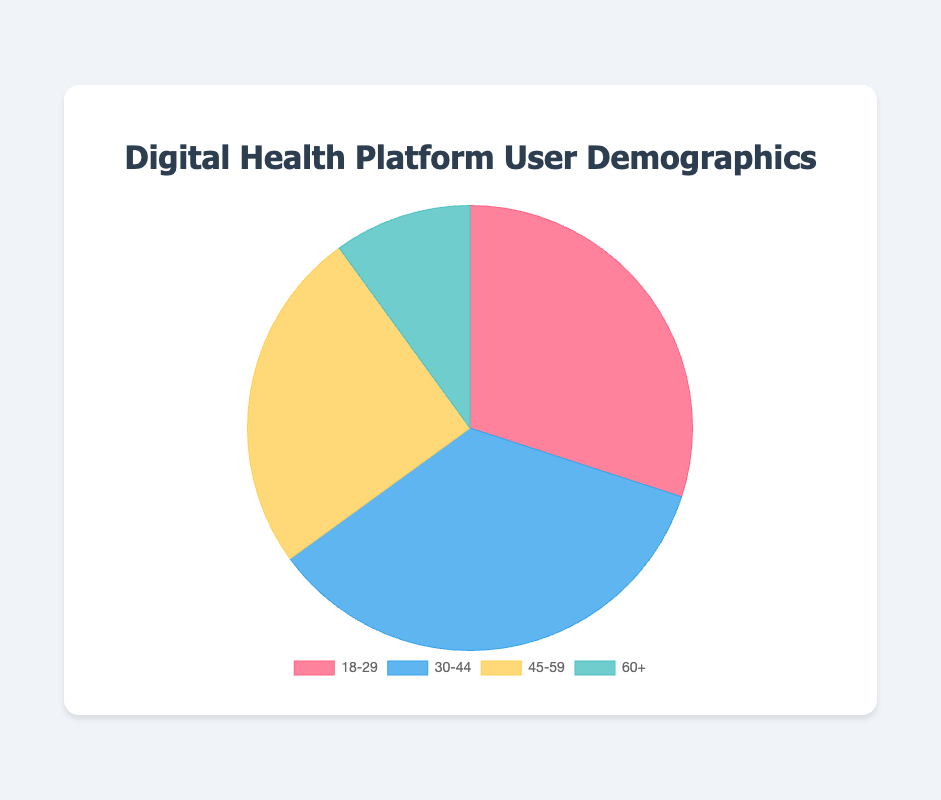What age group represents the largest percentage of users? The 30-44 age group has the largest slice in the pie chart with a percentage of 35%.
Answer: 30-44 Which age group has the smallest representation? The 60+ age group is the smallest slice in the pie chart with a percentage of 10%.
Answer: 60+ What is the combined percentage of users aged 18-29 and 45-59? Add the percentages of the 18-29 and 45-59 age groups: 30% + 25%.
Answer: 55% How does the percentage of users aged 18-29 compare to those aged 30-44? The 30-44 age group (35%) is larger than the 18-29 age group (30%).
Answer: 30-44 > 18-29 Which color represents the 45-59 age group? The 45-59 age group is represented by the yellow slice in the pie chart.
Answer: Yellow What is the total percentage of users aged below 45? Combine the percentages of the 18-29 and 30-44 age groups: 30% + 35%.
Answer: 65% What is the percentage difference between the 30-44 and 60+ age groups? Subtract the percentage of the 60+ age group from that of the 30-44 age group: 35% - 10%.
Answer: 25% Which age groups account for at least 25% of the user base? Both the 18-29 (30%) and 30-44 (35%) age groups represent at least 25% each.
Answer: 18-29 and 30-44 Combine the 45-59 and 60+ age groups, what fraction of the total user base do they represent? Add the percentages of the 45-59 and 60+ age groups: 25% + 10%, which together form 35% of the user base.
Answer: 35% 